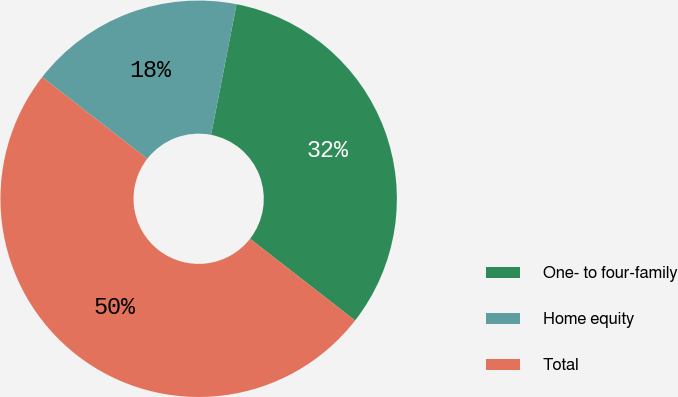<chart> <loc_0><loc_0><loc_500><loc_500><pie_chart><fcel>One- to four-family<fcel>Home equity<fcel>Total<nl><fcel>32.46%<fcel>17.54%<fcel>50.0%<nl></chart> 